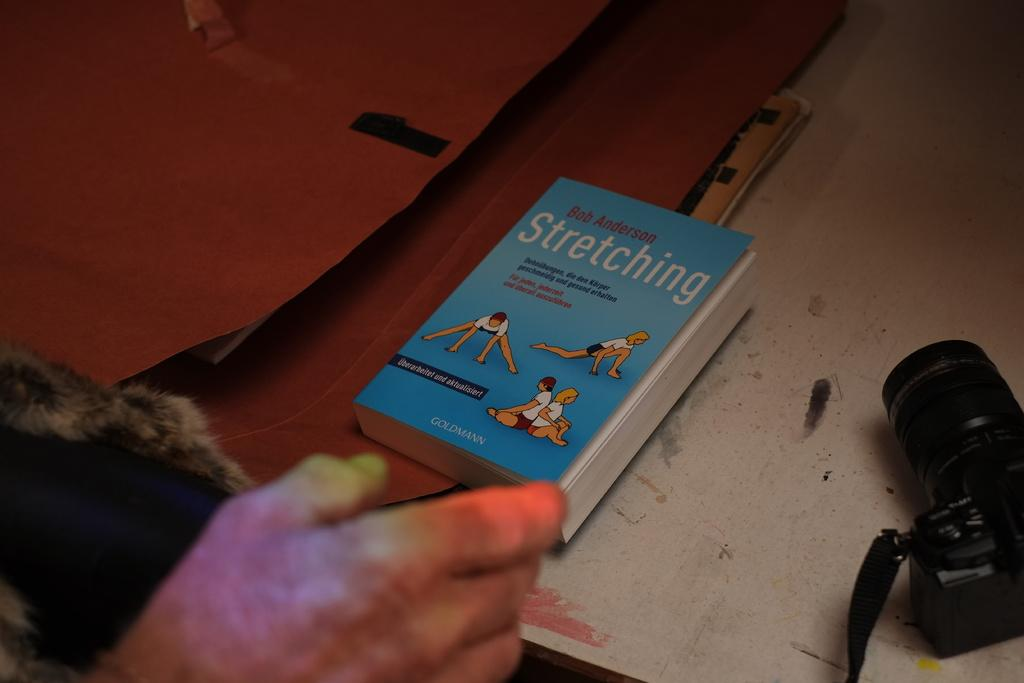What part of a person is visible in the image? There is a hand of a person in the image. What is in front of the hand? There is a table in front of the hand. What items can be seen on the table? There is a book and a camera on the table, along with other objects. What direction is the sun shining from in the image? There is no sun visible in the image, so it is not possible to determine the direction of sunlight. 